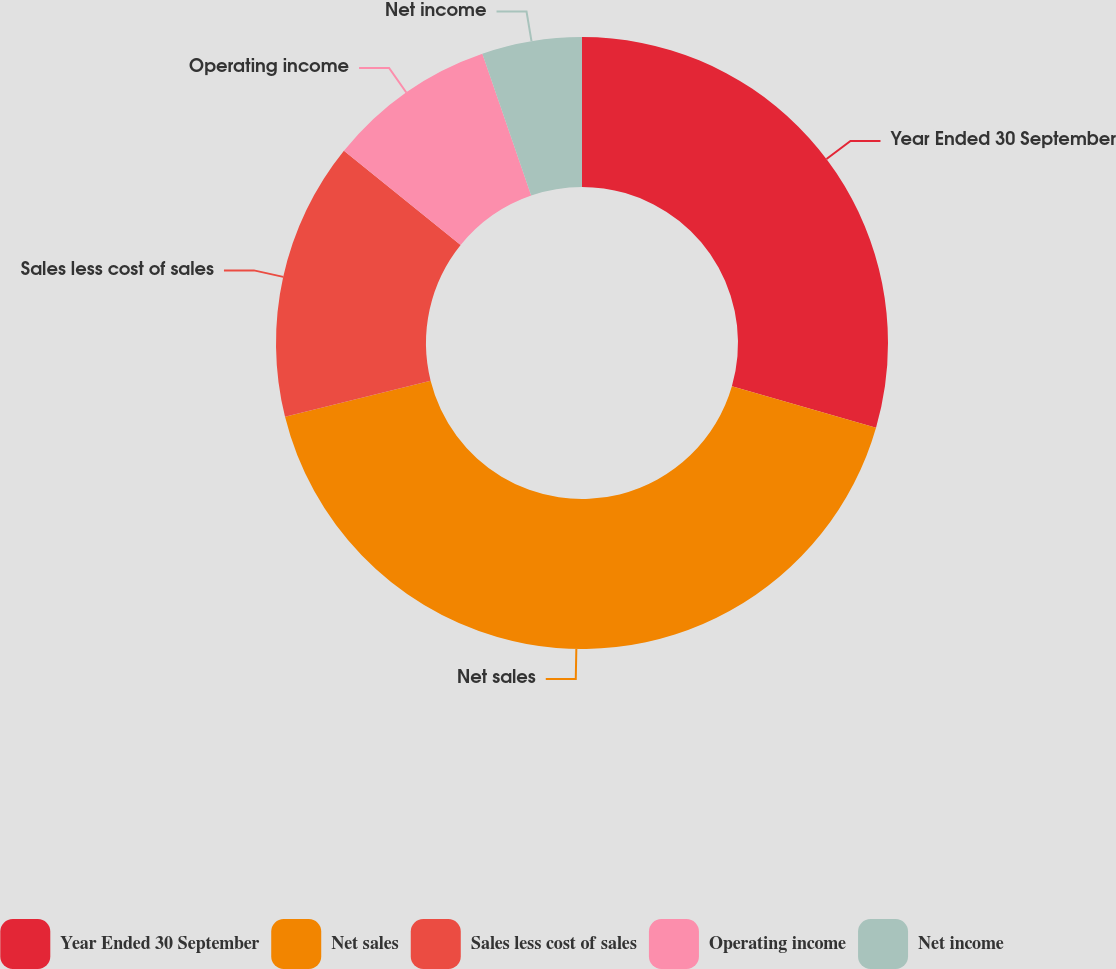<chart> <loc_0><loc_0><loc_500><loc_500><pie_chart><fcel>Year Ended 30 September<fcel>Net sales<fcel>Sales less cost of sales<fcel>Operating income<fcel>Net income<nl><fcel>29.47%<fcel>41.66%<fcel>14.69%<fcel>8.91%<fcel>5.28%<nl></chart> 